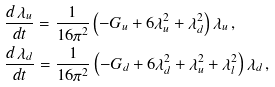<formula> <loc_0><loc_0><loc_500><loc_500>& \frac { d \, \lambda _ { u } } { d t } = \frac { 1 } { 1 6 \pi ^ { 2 } } \left ( - G _ { u } + 6 \lambda _ { u } ^ { 2 } + \lambda _ { d } ^ { 2 } \right ) \lambda _ { u } \, , \\ & \frac { d \, \lambda _ { d } } { d t } = \frac { 1 } { 1 6 \pi ^ { 2 } } \left ( - G _ { d } + 6 \lambda _ { d } ^ { 2 } + \lambda _ { u } ^ { 2 } + \lambda _ { l } ^ { 2 } \right ) \lambda _ { d } \, ,</formula> 